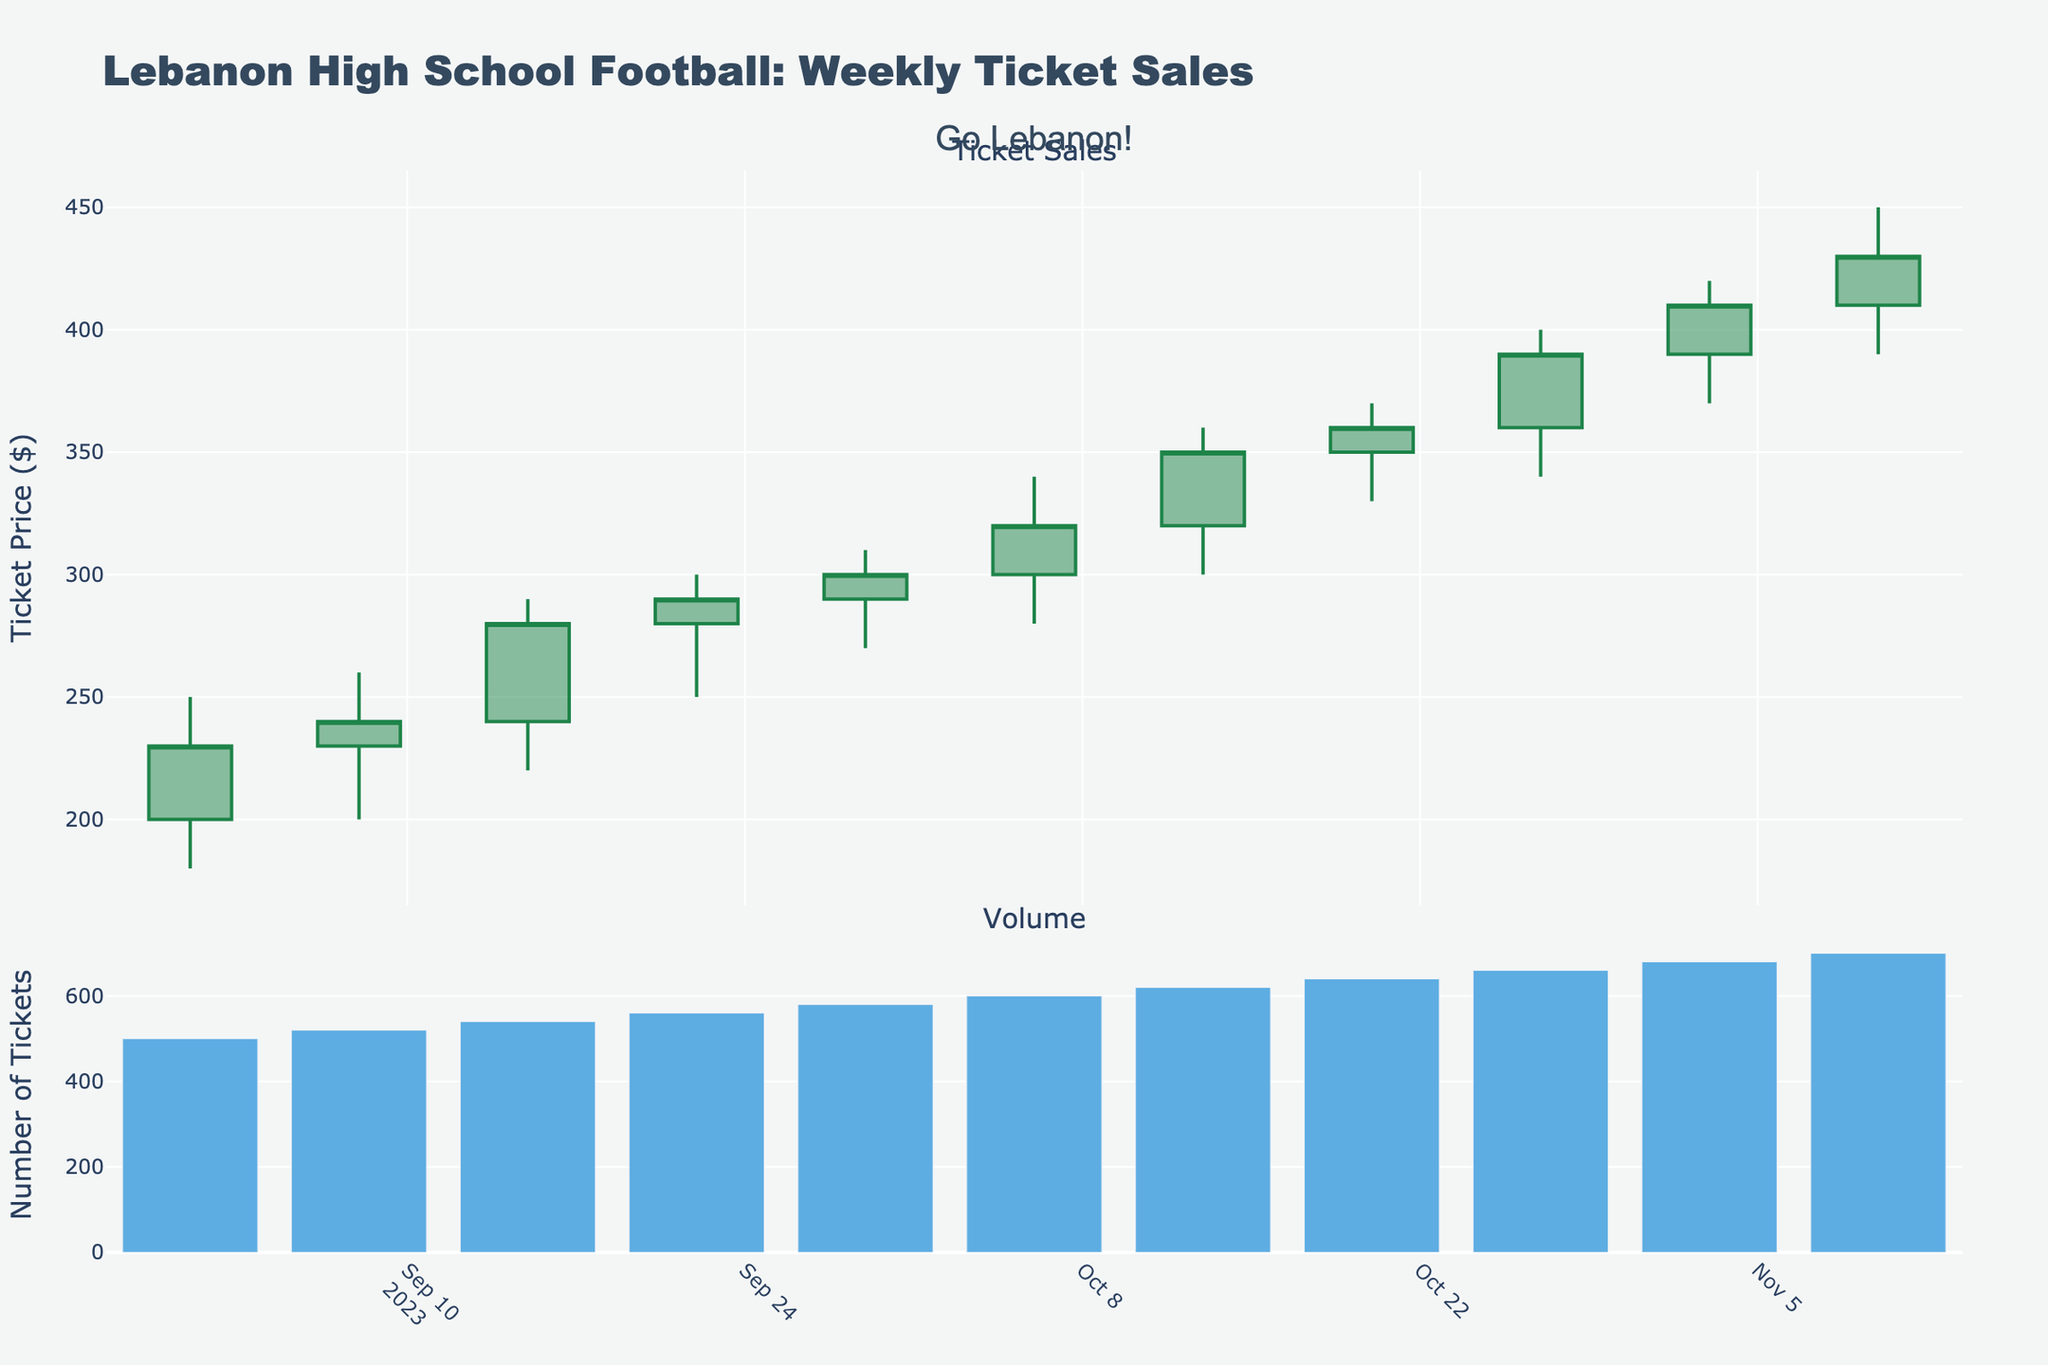What is the title of the figure? The title of the figure is located at the top of the plot and is centered. It reads "Lebanon High School Football: Weekly Ticket Sales".
Answer: Lebanon High School Football: Weekly Ticket Sales How many weeks does the plot cover? The x-axis has dates from 2023-09-01 to 2023-11-10, which indicates that the plot covers each week in this range. Counting the dates shows that there are 11 weeks covered.
Answer: 11 What's the highest ticket price recorded during this period? Looking at the candlestick plot, the highest point on the 'High' values represents the highest ticket price. This occurs on 2023-11-10 with a value of $450.
Answer: $450 What is the volume of tickets sold on 2023-10-27? The bar graph at the bottom of the figure shows the volume of tickets sold each week. Referencing the date 2023-10-27, the corresponding bar reaches up to 660 tickets.
Answer: 660 How did the closing ticket price change from 2023-09-01 to 2023-11-10? The closing ticket price on 2023-09-01 was $230. By 2023-11-10, it increased to $430. The change in closing price can be calculated by subtracting the initial value from the final value: $430 - $230 = $200.
Answer: Increased by $200 Which week saw the largest increase in closing ticket price compared to the previous week? By comparing the closing prices from one week to the next, the week with the largest difference between consecutive closing prices is 2023-10-27 to 2023-11-03. The closing price increased from $390 to $410, a difference of $20.
Answer: 2023-11-03 In which week did the ticket prices reach their lowest point? The lowest point in the candlestick plot is the 'Low' value of $180 on 2023-09-01.
Answer: 2023-09-01 What is the average weekly ticket volume over the entire period? The total volume is the sum of all weekly volumes: 500 + 520 + 540 + 560 + 580 + 600 + 620 + 640 + 660 + 680 + 700 = 6600. The average is 6600 divided by the number of weeks (11): 6600 / 11 = 600.
Answer: 600 How does the height of the green candles compare to the red candles in the candlestick chart? Green candles indicate increasing prices, while red candles indicate decreasing prices. By observing the chart, there are more tall green candles than red ones, suggesting stronger upward movements most of the weeks.
Answer: More green candles Which week had the smallest range of ticket prices? The range is calculated as High minus Low for each week. The smallest range is on 2023-09-08, where the High is $260 and the Low is $200, giving a range of $60.
Answer: 2023-09-08 